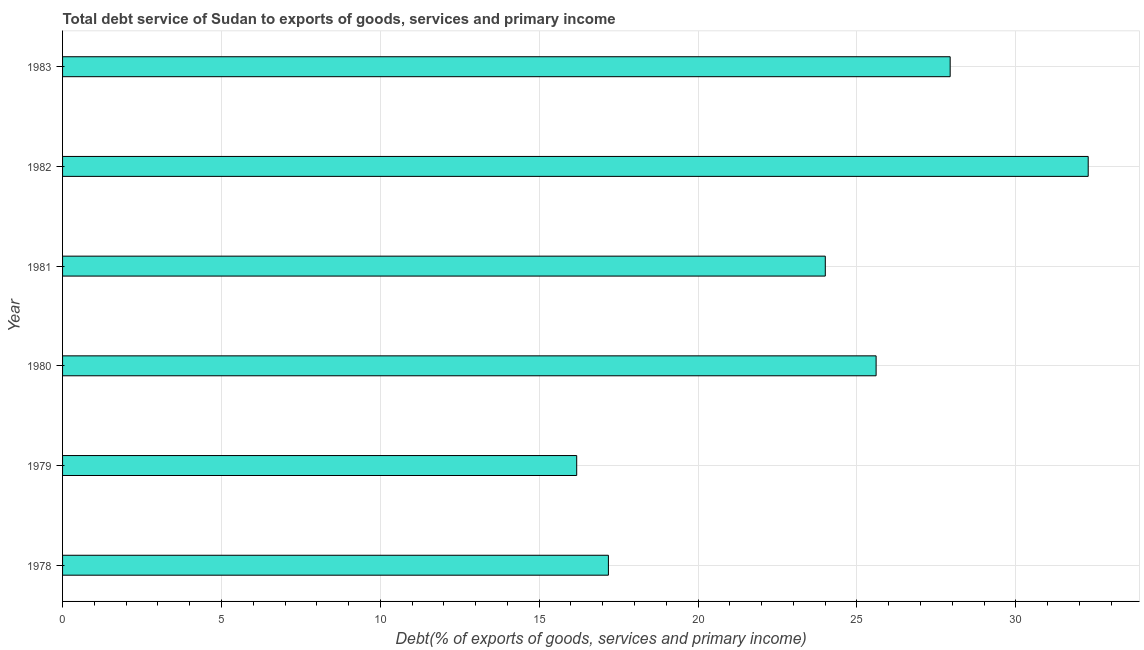Does the graph contain any zero values?
Your answer should be compact. No. Does the graph contain grids?
Keep it short and to the point. Yes. What is the title of the graph?
Provide a short and direct response. Total debt service of Sudan to exports of goods, services and primary income. What is the label or title of the X-axis?
Offer a terse response. Debt(% of exports of goods, services and primary income). What is the total debt service in 1978?
Make the answer very short. 17.18. Across all years, what is the maximum total debt service?
Give a very brief answer. 32.28. Across all years, what is the minimum total debt service?
Ensure brevity in your answer.  16.18. In which year was the total debt service maximum?
Offer a very short reply. 1982. In which year was the total debt service minimum?
Your answer should be compact. 1979. What is the sum of the total debt service?
Give a very brief answer. 143.18. What is the difference between the total debt service in 1980 and 1982?
Offer a terse response. -6.67. What is the average total debt service per year?
Ensure brevity in your answer.  23.86. What is the median total debt service?
Provide a succinct answer. 24.8. Do a majority of the years between 1979 and 1981 (inclusive) have total debt service greater than 26 %?
Give a very brief answer. No. What is the ratio of the total debt service in 1979 to that in 1983?
Your answer should be very brief. 0.58. Is the difference between the total debt service in 1979 and 1980 greater than the difference between any two years?
Give a very brief answer. No. What is the difference between the highest and the second highest total debt service?
Provide a succinct answer. 4.34. What is the difference between the highest and the lowest total debt service?
Make the answer very short. 16.1. How many bars are there?
Offer a terse response. 6. What is the difference between two consecutive major ticks on the X-axis?
Your answer should be very brief. 5. What is the Debt(% of exports of goods, services and primary income) of 1978?
Keep it short and to the point. 17.18. What is the Debt(% of exports of goods, services and primary income) of 1979?
Your response must be concise. 16.18. What is the Debt(% of exports of goods, services and primary income) of 1980?
Your answer should be very brief. 25.6. What is the Debt(% of exports of goods, services and primary income) of 1981?
Make the answer very short. 24. What is the Debt(% of exports of goods, services and primary income) of 1982?
Give a very brief answer. 32.28. What is the Debt(% of exports of goods, services and primary income) in 1983?
Your answer should be very brief. 27.93. What is the difference between the Debt(% of exports of goods, services and primary income) in 1978 and 1979?
Your answer should be very brief. 1. What is the difference between the Debt(% of exports of goods, services and primary income) in 1978 and 1980?
Your answer should be very brief. -8.43. What is the difference between the Debt(% of exports of goods, services and primary income) in 1978 and 1981?
Offer a terse response. -6.83. What is the difference between the Debt(% of exports of goods, services and primary income) in 1978 and 1982?
Offer a terse response. -15.1. What is the difference between the Debt(% of exports of goods, services and primary income) in 1978 and 1983?
Your answer should be compact. -10.76. What is the difference between the Debt(% of exports of goods, services and primary income) in 1979 and 1980?
Ensure brevity in your answer.  -9.42. What is the difference between the Debt(% of exports of goods, services and primary income) in 1979 and 1981?
Give a very brief answer. -7.82. What is the difference between the Debt(% of exports of goods, services and primary income) in 1979 and 1982?
Make the answer very short. -16.1. What is the difference between the Debt(% of exports of goods, services and primary income) in 1979 and 1983?
Your answer should be very brief. -11.75. What is the difference between the Debt(% of exports of goods, services and primary income) in 1980 and 1981?
Offer a terse response. 1.6. What is the difference between the Debt(% of exports of goods, services and primary income) in 1980 and 1982?
Provide a succinct answer. -6.67. What is the difference between the Debt(% of exports of goods, services and primary income) in 1980 and 1983?
Your answer should be very brief. -2.33. What is the difference between the Debt(% of exports of goods, services and primary income) in 1981 and 1982?
Your answer should be very brief. -8.27. What is the difference between the Debt(% of exports of goods, services and primary income) in 1981 and 1983?
Your response must be concise. -3.93. What is the difference between the Debt(% of exports of goods, services and primary income) in 1982 and 1983?
Offer a terse response. 4.34. What is the ratio of the Debt(% of exports of goods, services and primary income) in 1978 to that in 1979?
Offer a very short reply. 1.06. What is the ratio of the Debt(% of exports of goods, services and primary income) in 1978 to that in 1980?
Make the answer very short. 0.67. What is the ratio of the Debt(% of exports of goods, services and primary income) in 1978 to that in 1981?
Your answer should be compact. 0.72. What is the ratio of the Debt(% of exports of goods, services and primary income) in 1978 to that in 1982?
Ensure brevity in your answer.  0.53. What is the ratio of the Debt(% of exports of goods, services and primary income) in 1978 to that in 1983?
Provide a short and direct response. 0.61. What is the ratio of the Debt(% of exports of goods, services and primary income) in 1979 to that in 1980?
Give a very brief answer. 0.63. What is the ratio of the Debt(% of exports of goods, services and primary income) in 1979 to that in 1981?
Provide a short and direct response. 0.67. What is the ratio of the Debt(% of exports of goods, services and primary income) in 1979 to that in 1982?
Your response must be concise. 0.5. What is the ratio of the Debt(% of exports of goods, services and primary income) in 1979 to that in 1983?
Offer a terse response. 0.58. What is the ratio of the Debt(% of exports of goods, services and primary income) in 1980 to that in 1981?
Provide a short and direct response. 1.07. What is the ratio of the Debt(% of exports of goods, services and primary income) in 1980 to that in 1982?
Your response must be concise. 0.79. What is the ratio of the Debt(% of exports of goods, services and primary income) in 1980 to that in 1983?
Offer a very short reply. 0.92. What is the ratio of the Debt(% of exports of goods, services and primary income) in 1981 to that in 1982?
Give a very brief answer. 0.74. What is the ratio of the Debt(% of exports of goods, services and primary income) in 1981 to that in 1983?
Offer a very short reply. 0.86. What is the ratio of the Debt(% of exports of goods, services and primary income) in 1982 to that in 1983?
Your answer should be compact. 1.16. 